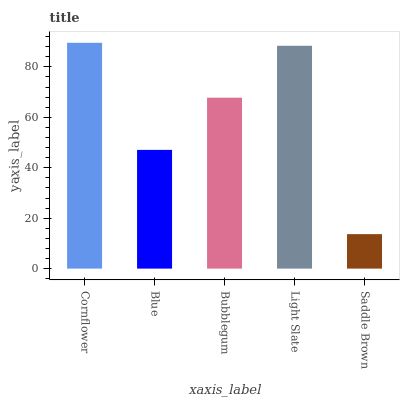Is Blue the minimum?
Answer yes or no. No. Is Blue the maximum?
Answer yes or no. No. Is Cornflower greater than Blue?
Answer yes or no. Yes. Is Blue less than Cornflower?
Answer yes or no. Yes. Is Blue greater than Cornflower?
Answer yes or no. No. Is Cornflower less than Blue?
Answer yes or no. No. Is Bubblegum the high median?
Answer yes or no. Yes. Is Bubblegum the low median?
Answer yes or no. Yes. Is Light Slate the high median?
Answer yes or no. No. Is Blue the low median?
Answer yes or no. No. 